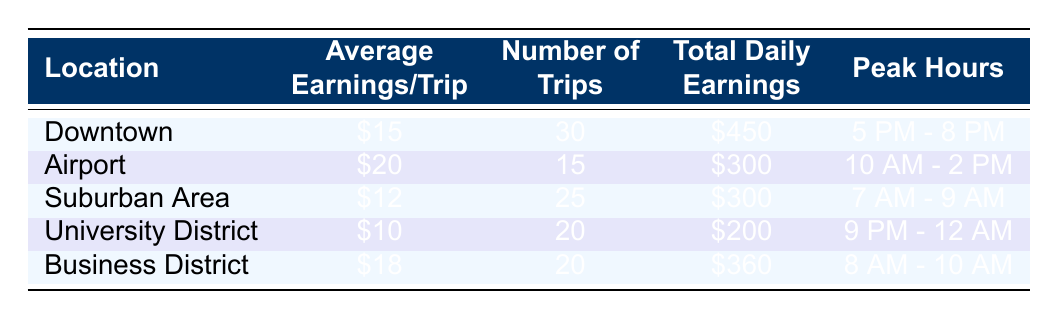What is the average earnings per trip in the Airport location? The table shows that the average earnings per trip in the Airport location is listed as $20.
Answer: 20 Which location has the highest total daily earnings? By comparing the total daily earnings across all locations, I see that Downtown has total earnings of $450, which is higher than any other locations listed.
Answer: Downtown How many trips were taken in the Business District? According to the table, the number of trips taken in the Business District is 20.
Answer: 20 What is the total number of trips across all locations? I can calculate the total number of trips by adding the number of trips for each location: 30 (Downtown) + 15 (Airport) + 25 (Suburban Area) + 20 (University District) + 20 (Business District) = 110.
Answer: 110 Is the average earnings per trip in the University District higher than that in the Suburban Area? Looking at the table, the average earnings per trip in the University District is $10, while in the Suburban Area it is $12. Therefore, the average earnings in the University District is not higher than in the Suburban Area.
Answer: No Which location has the peak hours from 7 AM to 9 AM? The table indicates that the Suburban Area has the peak hours listed as 7 AM - 9 AM.
Answer: Suburban Area Calculate the average total daily earnings across all locations. To find the average total daily earnings, I sum the total daily earnings: $450 (Downtown) + $300 (Airport) + $300 (Suburban Area) + $200 (University District) + $360 (Business District) = $1,610. There are 5 locations, so the average is $1,610 / 5 = $322.
Answer: 322 In which location are the peak hours from 9 PM to 12 AM? According to the table, the University District has peak hours from 9 PM - 12 AM.
Answer: University District Which location has the lowest average earnings per trip? By reviewing the average earnings per trip, I've noted that the University District has the lowest at $10.
Answer: University District 